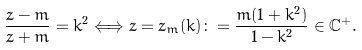<formula> <loc_0><loc_0><loc_500><loc_500>\frac { z - m } { z + m } = k ^ { 2 } \Longleftrightarrow z = z _ { m } ( k ) \colon = \frac { m ( 1 + k ^ { 2 } ) } { 1 - k ^ { 2 } } \in \mathbb { C } ^ { + } .</formula> 